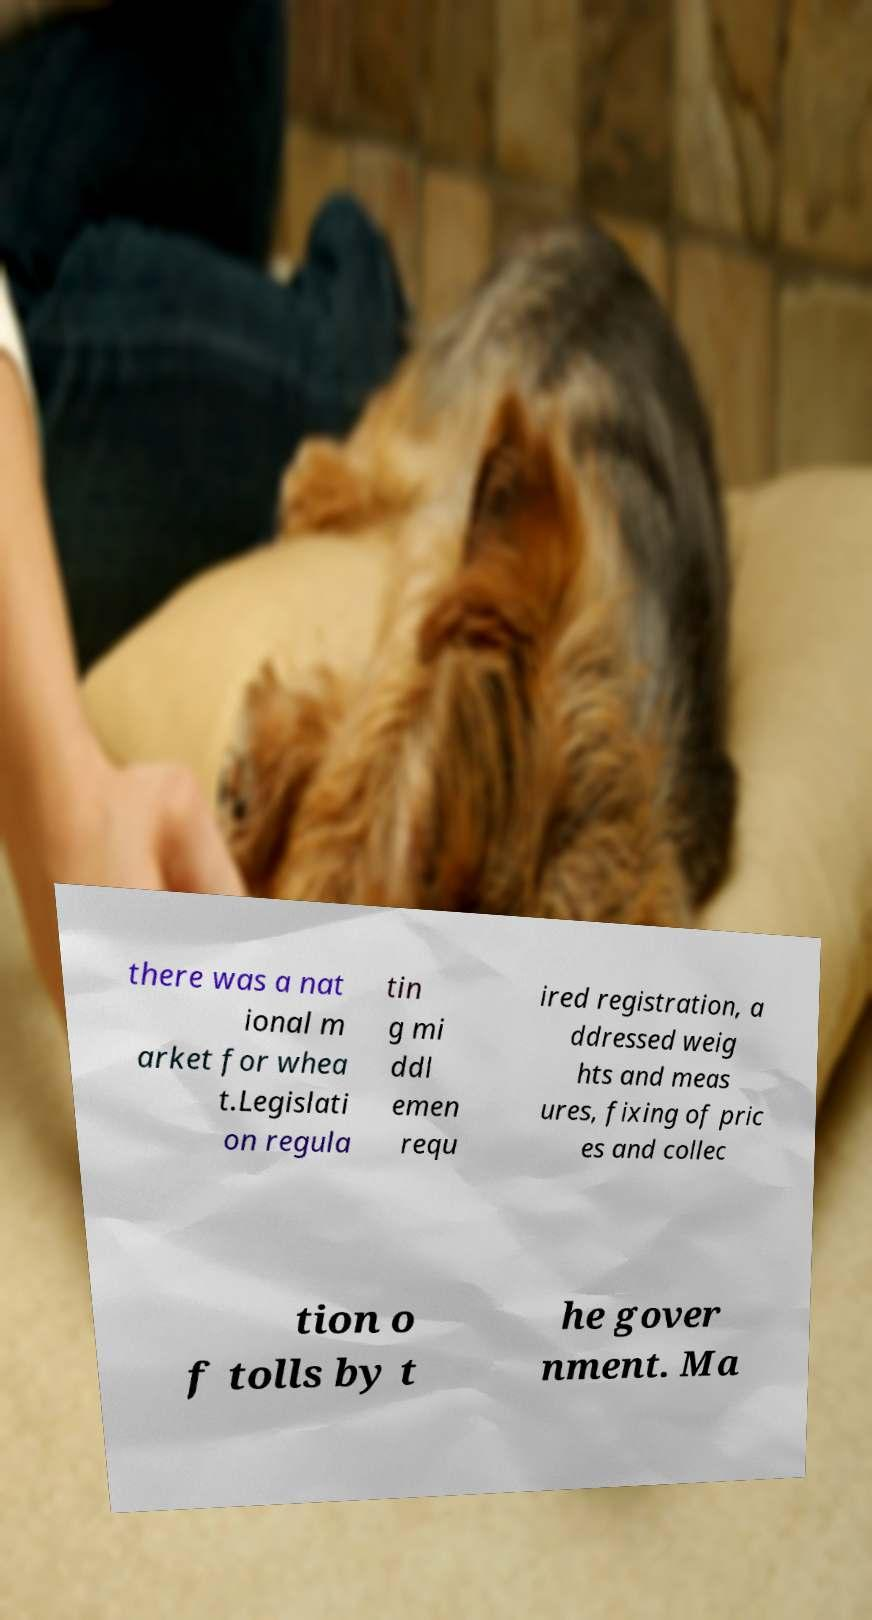Please read and relay the text visible in this image. What does it say? there was a nat ional m arket for whea t.Legislati on regula tin g mi ddl emen requ ired registration, a ddressed weig hts and meas ures, fixing of pric es and collec tion o f tolls by t he gover nment. Ma 